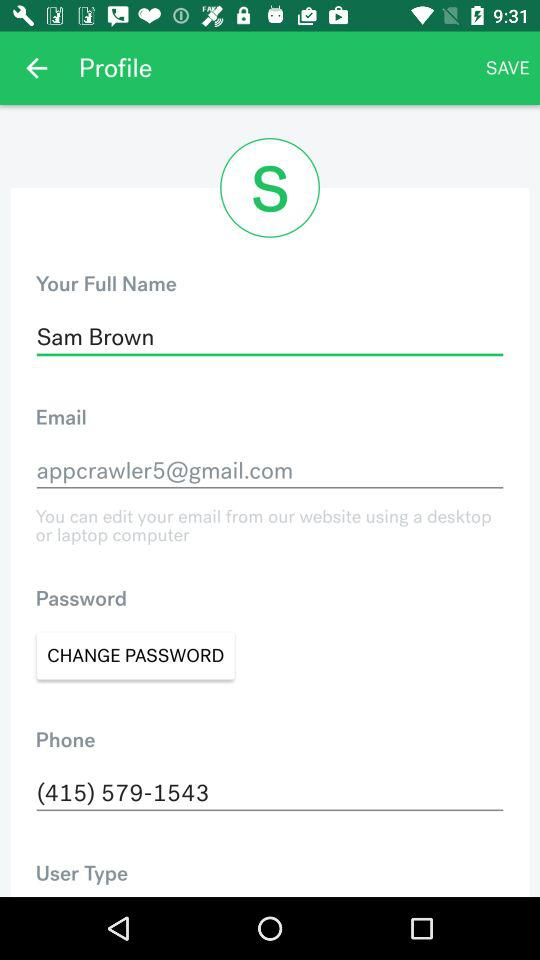What is the email address? The email address is appcrawler5@gmail.com. 